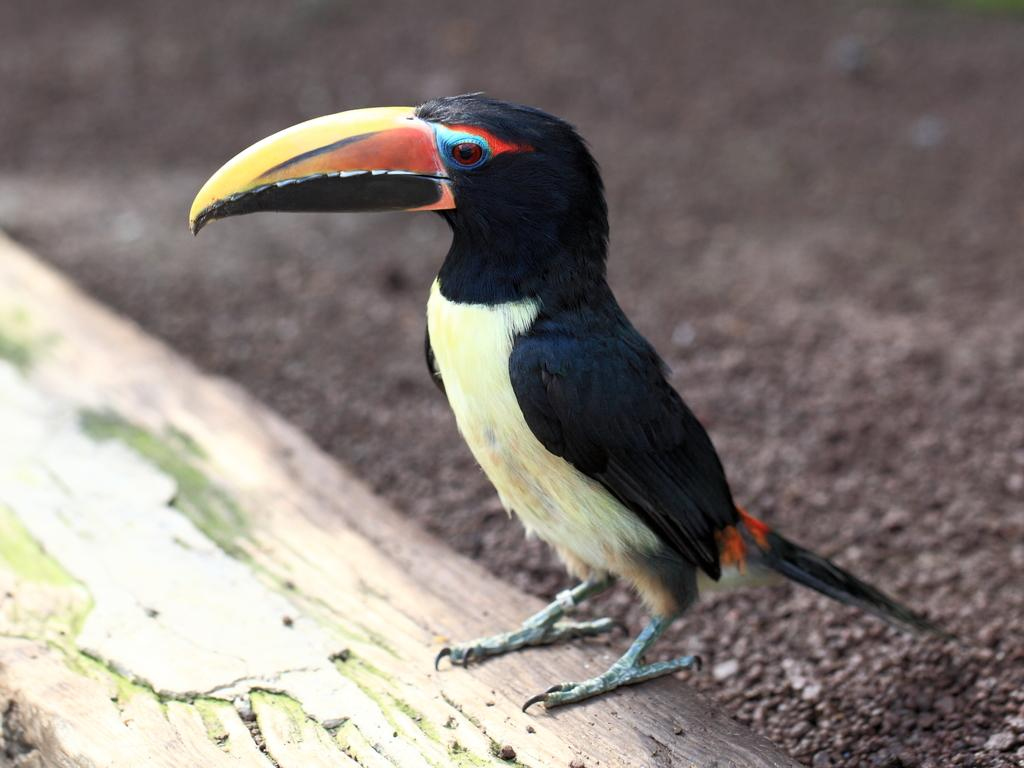What type of animal can be seen in the image? There is a bird in the image. Where is the bird located in the image? The bird is on a tree trunk. What type of terrain is visible in the image? Sand is visible in the image. Can you determine the time of day when the image was taken? The image was likely taken during the day, as there are no visible indications of nighttime. What type of chalk effect can be seen on the bird in the image? There is no chalk effect present on the bird in the image. What level of detail can be observed on the bird's feathers in the image? The level of detail on the bird's feathers cannot be determined from the image alone, as the resolution or quality of the image may affect the visibility of such details. 